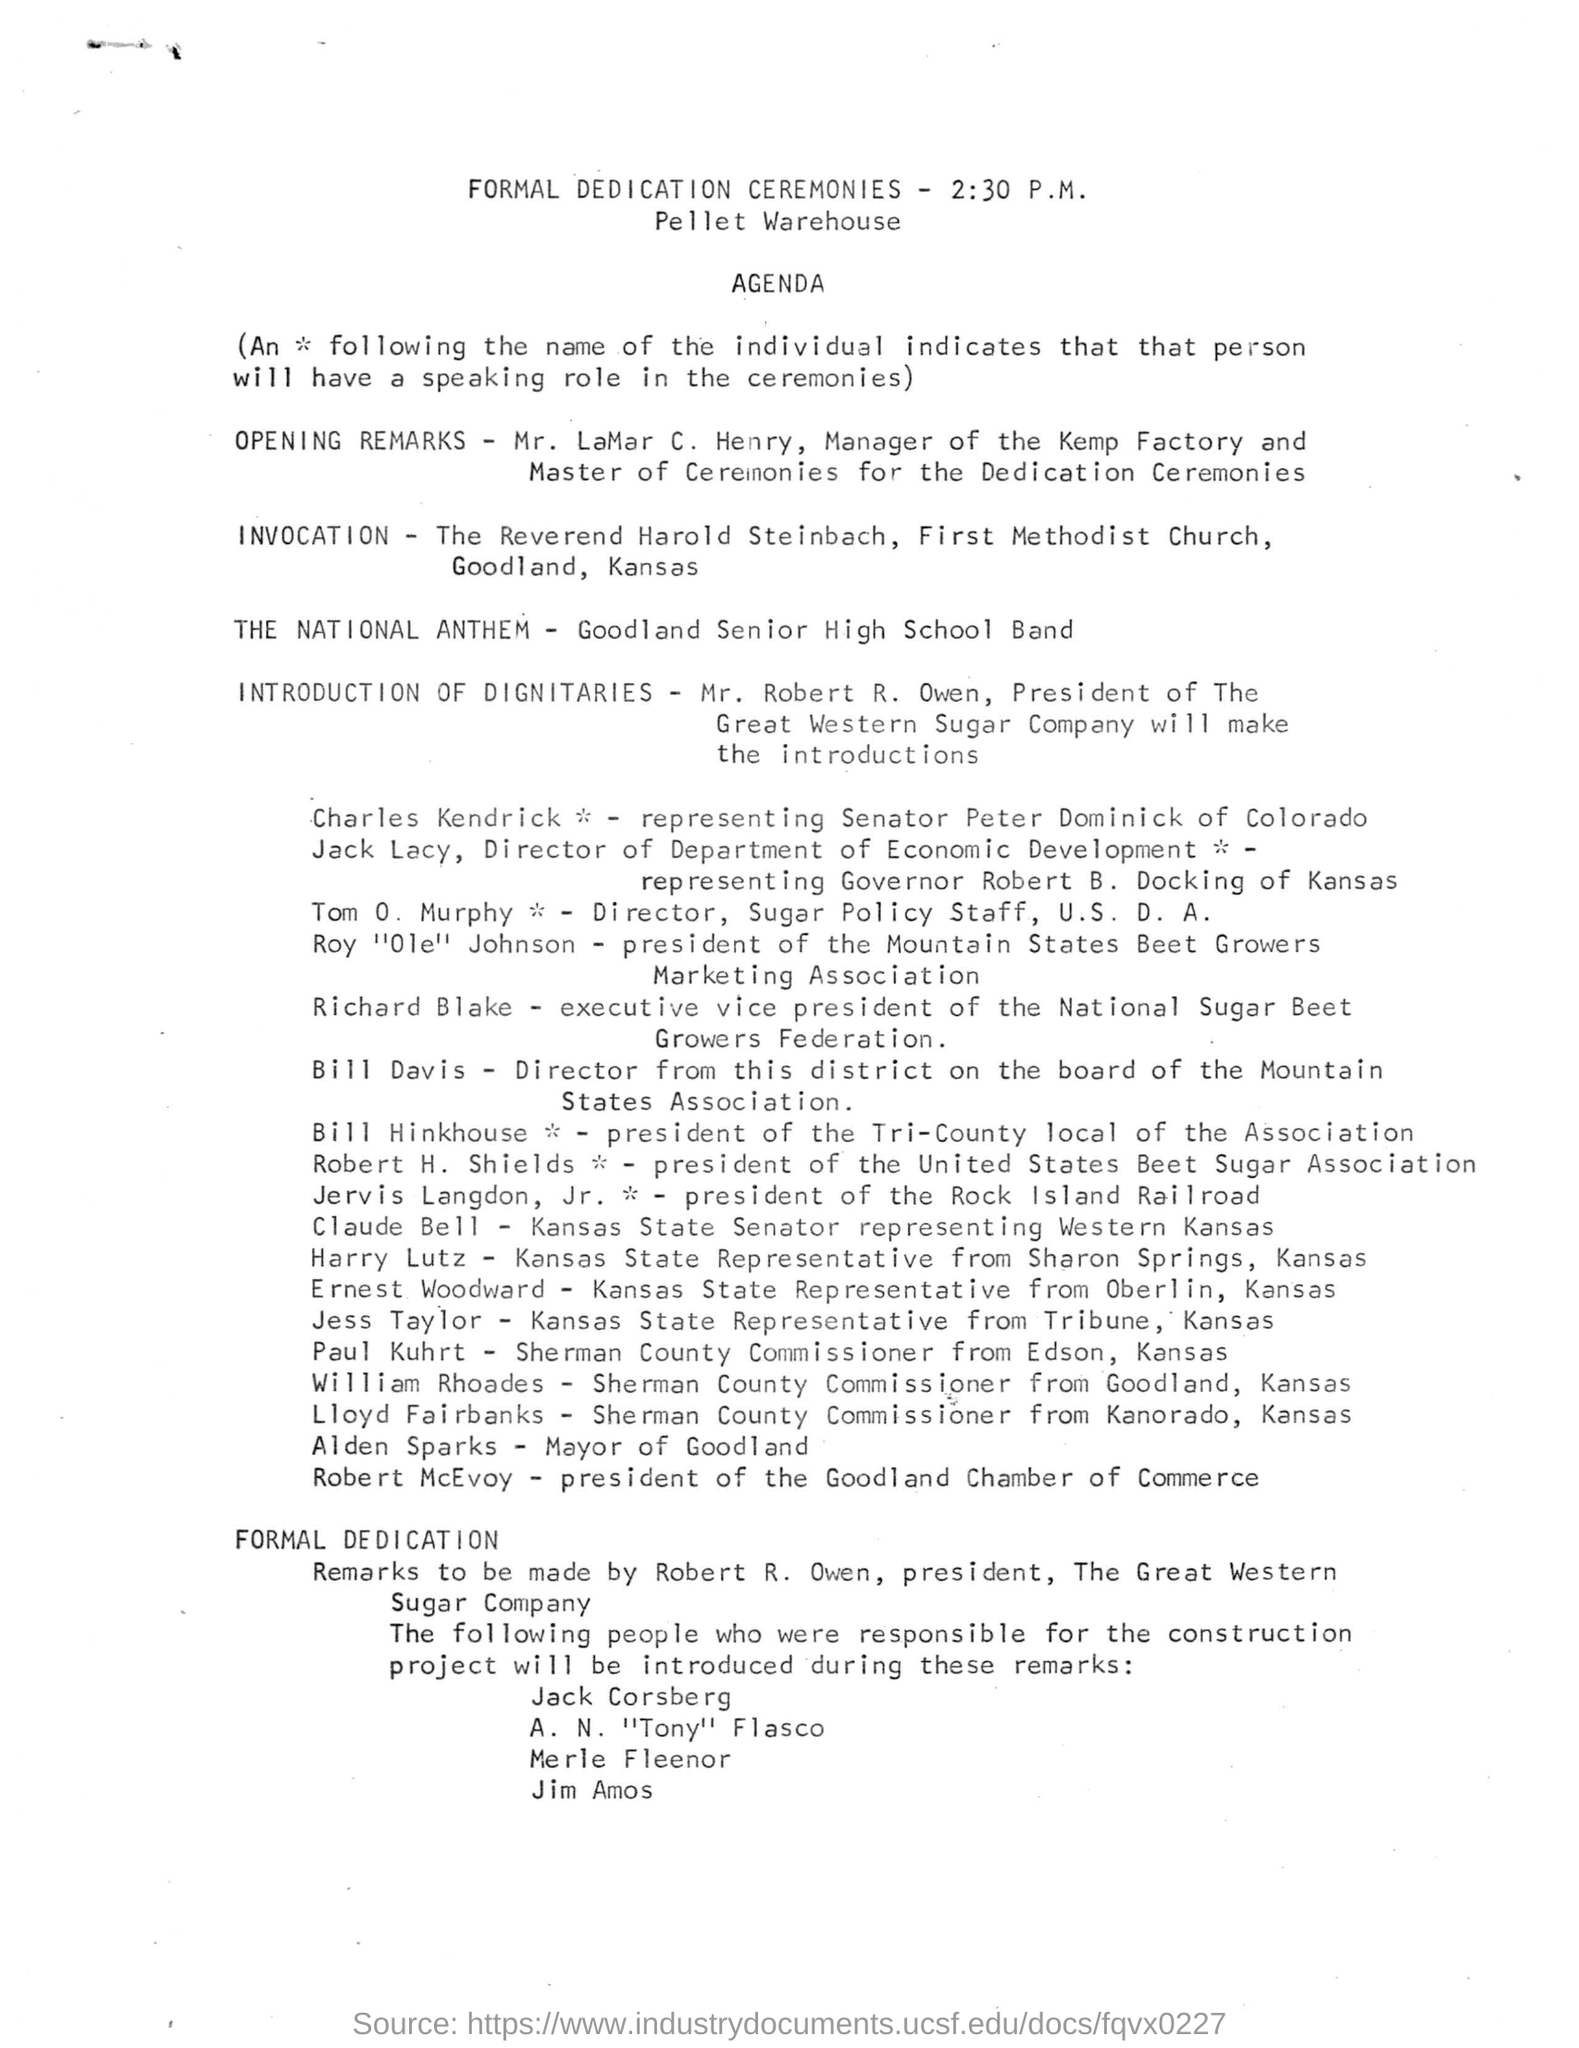When is the formal dedication ceremonies held?
Make the answer very short. 2:30 P.M. Who is presenting the opening remarks as per the agenda?
Your answer should be very brief. Mr. LaMar C. Henry. Which band is performing the National Anthem?
Offer a very short reply. Goodland Senior High School Band. Who is giving the introduction of Dignitaries?
Give a very brief answer. Mr. Robert R. Owen. What is the designation of Mr. Robert R. Owen?
Keep it short and to the point. President. Who is the executive vice president of the National Sugar Beet Growers Federation?
Your response must be concise. Richard Blake. Where is the formal dedication ceremonies held?
Your answer should be compact. Pellet Warehouse. What is the designation of Tom O. Murphy?
Provide a succinct answer. Director, Sugar Policy Staff, U.S. D. A. 